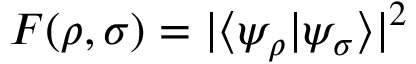<formula> <loc_0><loc_0><loc_500><loc_500>F ( \rho , \sigma ) = | \langle \psi _ { \rho } | \psi _ { \sigma } \rangle | ^ { 2 }</formula> 